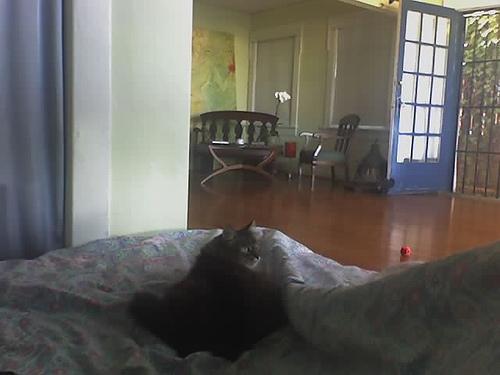How many giraffes are looking away from the camera?
Give a very brief answer. 0. 